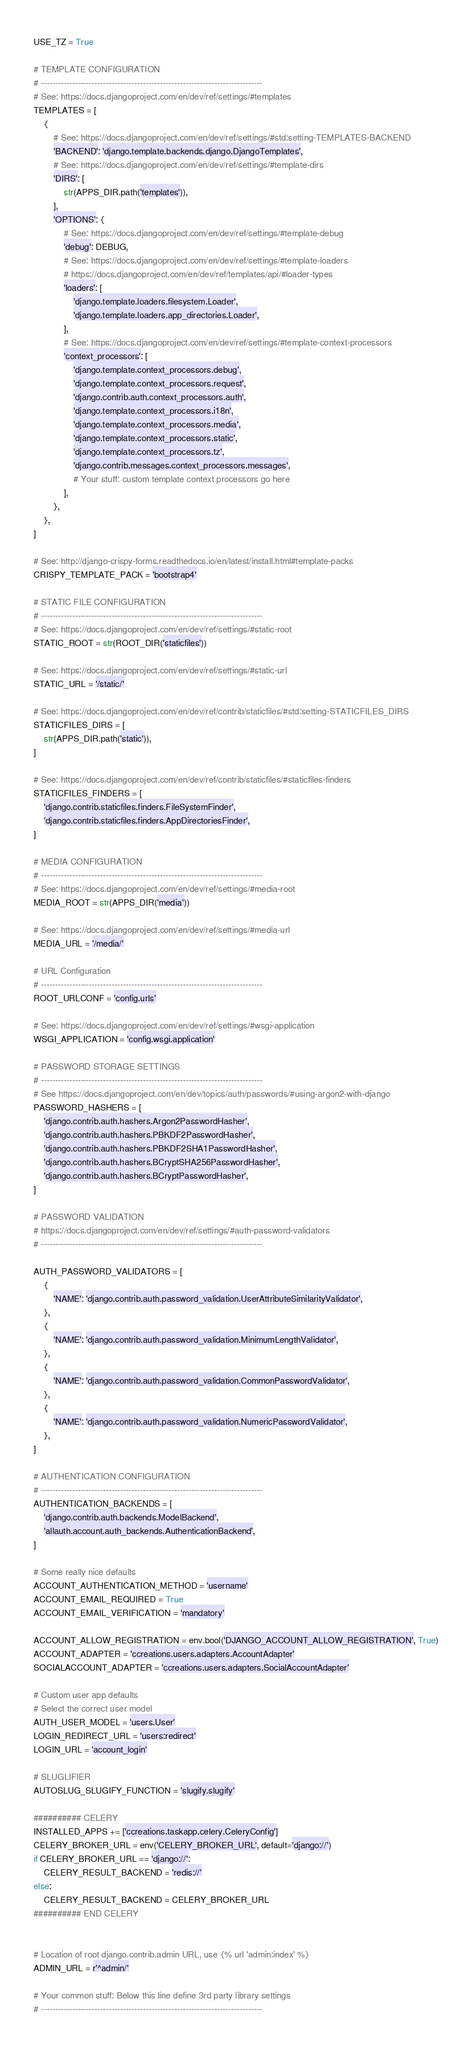<code> <loc_0><loc_0><loc_500><loc_500><_Python_>USE_TZ = True

# TEMPLATE CONFIGURATION
# ------------------------------------------------------------------------------
# See: https://docs.djangoproject.com/en/dev/ref/settings/#templates
TEMPLATES = [
    {
        # See: https://docs.djangoproject.com/en/dev/ref/settings/#std:setting-TEMPLATES-BACKEND
        'BACKEND': 'django.template.backends.django.DjangoTemplates',
        # See: https://docs.djangoproject.com/en/dev/ref/settings/#template-dirs
        'DIRS': [
            str(APPS_DIR.path('templates')),
        ],
        'OPTIONS': {
            # See: https://docs.djangoproject.com/en/dev/ref/settings/#template-debug
            'debug': DEBUG,
            # See: https://docs.djangoproject.com/en/dev/ref/settings/#template-loaders
            # https://docs.djangoproject.com/en/dev/ref/templates/api/#loader-types
            'loaders': [
                'django.template.loaders.filesystem.Loader',
                'django.template.loaders.app_directories.Loader',
            ],
            # See: https://docs.djangoproject.com/en/dev/ref/settings/#template-context-processors
            'context_processors': [
                'django.template.context_processors.debug',
                'django.template.context_processors.request',
                'django.contrib.auth.context_processors.auth',
                'django.template.context_processors.i18n',
                'django.template.context_processors.media',
                'django.template.context_processors.static',
                'django.template.context_processors.tz',
                'django.contrib.messages.context_processors.messages',
                # Your stuff: custom template context processors go here
            ],
        },
    },
]

# See: http://django-crispy-forms.readthedocs.io/en/latest/install.html#template-packs
CRISPY_TEMPLATE_PACK = 'bootstrap4'

# STATIC FILE CONFIGURATION
# ------------------------------------------------------------------------------
# See: https://docs.djangoproject.com/en/dev/ref/settings/#static-root
STATIC_ROOT = str(ROOT_DIR('staticfiles'))

# See: https://docs.djangoproject.com/en/dev/ref/settings/#static-url
STATIC_URL = '/static/'

# See: https://docs.djangoproject.com/en/dev/ref/contrib/staticfiles/#std:setting-STATICFILES_DIRS
STATICFILES_DIRS = [
    str(APPS_DIR.path('static')),
]

# See: https://docs.djangoproject.com/en/dev/ref/contrib/staticfiles/#staticfiles-finders
STATICFILES_FINDERS = [
    'django.contrib.staticfiles.finders.FileSystemFinder',
    'django.contrib.staticfiles.finders.AppDirectoriesFinder',
]

# MEDIA CONFIGURATION
# ------------------------------------------------------------------------------
# See: https://docs.djangoproject.com/en/dev/ref/settings/#media-root
MEDIA_ROOT = str(APPS_DIR('media'))

# See: https://docs.djangoproject.com/en/dev/ref/settings/#media-url
MEDIA_URL = '/media/'

# URL Configuration
# ------------------------------------------------------------------------------
ROOT_URLCONF = 'config.urls'

# See: https://docs.djangoproject.com/en/dev/ref/settings/#wsgi-application
WSGI_APPLICATION = 'config.wsgi.application'

# PASSWORD STORAGE SETTINGS
# ------------------------------------------------------------------------------
# See https://docs.djangoproject.com/en/dev/topics/auth/passwords/#using-argon2-with-django
PASSWORD_HASHERS = [
    'django.contrib.auth.hashers.Argon2PasswordHasher',
    'django.contrib.auth.hashers.PBKDF2PasswordHasher',
    'django.contrib.auth.hashers.PBKDF2SHA1PasswordHasher',
    'django.contrib.auth.hashers.BCryptSHA256PasswordHasher',
    'django.contrib.auth.hashers.BCryptPasswordHasher',
]

# PASSWORD VALIDATION
# https://docs.djangoproject.com/en/dev/ref/settings/#auth-password-validators
# ------------------------------------------------------------------------------

AUTH_PASSWORD_VALIDATORS = [
    {
        'NAME': 'django.contrib.auth.password_validation.UserAttributeSimilarityValidator',
    },
    {
        'NAME': 'django.contrib.auth.password_validation.MinimumLengthValidator',
    },
    {
        'NAME': 'django.contrib.auth.password_validation.CommonPasswordValidator',
    },
    {
        'NAME': 'django.contrib.auth.password_validation.NumericPasswordValidator',
    },
]

# AUTHENTICATION CONFIGURATION
# ------------------------------------------------------------------------------
AUTHENTICATION_BACKENDS = [
    'django.contrib.auth.backends.ModelBackend',
    'allauth.account.auth_backends.AuthenticationBackend',
]

# Some really nice defaults
ACCOUNT_AUTHENTICATION_METHOD = 'username'
ACCOUNT_EMAIL_REQUIRED = True
ACCOUNT_EMAIL_VERIFICATION = 'mandatory'

ACCOUNT_ALLOW_REGISTRATION = env.bool('DJANGO_ACCOUNT_ALLOW_REGISTRATION', True)
ACCOUNT_ADAPTER = 'ccreations.users.adapters.AccountAdapter'
SOCIALACCOUNT_ADAPTER = 'ccreations.users.adapters.SocialAccountAdapter'

# Custom user app defaults
# Select the correct user model
AUTH_USER_MODEL = 'users.User'
LOGIN_REDIRECT_URL = 'users:redirect'
LOGIN_URL = 'account_login'

# SLUGLIFIER
AUTOSLUG_SLUGIFY_FUNCTION = 'slugify.slugify'

########## CELERY
INSTALLED_APPS += ['ccreations.taskapp.celery.CeleryConfig']
CELERY_BROKER_URL = env('CELERY_BROKER_URL', default='django://')
if CELERY_BROKER_URL == 'django://':
    CELERY_RESULT_BACKEND = 'redis://'
else:
    CELERY_RESULT_BACKEND = CELERY_BROKER_URL
########## END CELERY


# Location of root django.contrib.admin URL, use {% url 'admin:index' %}
ADMIN_URL = r'^admin/'

# Your common stuff: Below this line define 3rd party library settings
# ------------------------------------------------------------------------------
</code> 